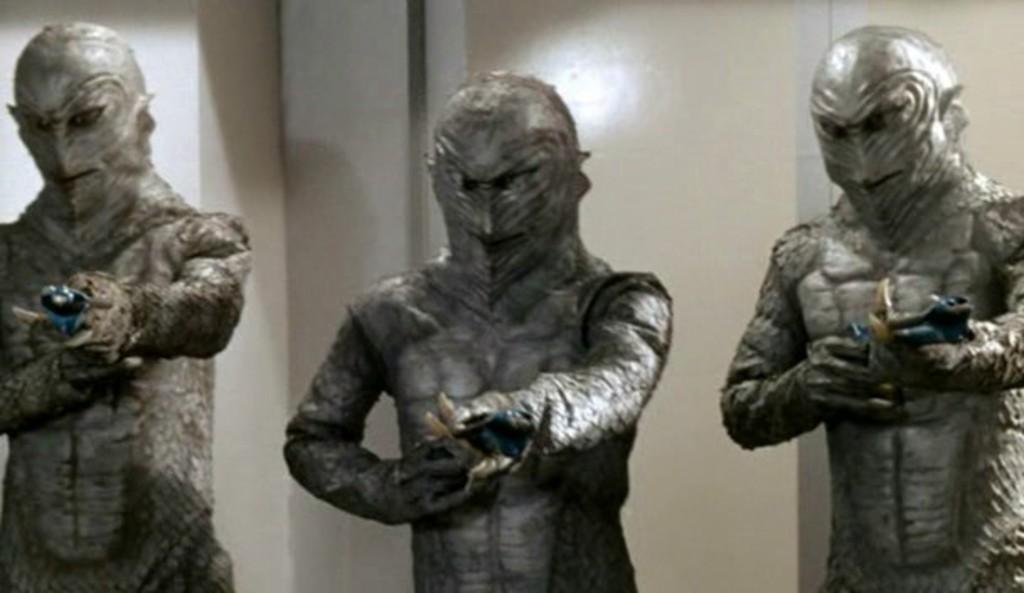How many statues are present in the image? There are three statues in the image. What are the statues doing in the image? Each statue is holding an object. What can be seen in the background of the image? There is a wall in the background of the image. What color is the orange hanging from the hook in the image? There is no orange or hook present in the image. How much debt is represented by the statues in the image? The statues in the image are not associated with any debt; they are holding objects. 